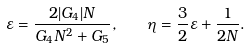Convert formula to latex. <formula><loc_0><loc_0><loc_500><loc_500>\varepsilon = \frac { 2 | G _ { 4 } | N } { G _ { 4 } N ^ { 2 } + G _ { 5 } } , \quad \eta = \frac { 3 } { 2 } \varepsilon + \frac { 1 } { 2 N } .</formula> 